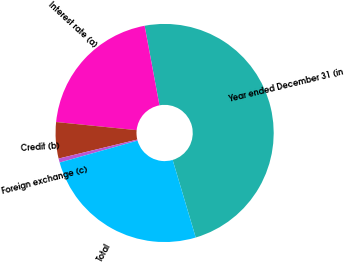<chart> <loc_0><loc_0><loc_500><loc_500><pie_chart><fcel>Year ended December 31 (in<fcel>Interest rate (a)<fcel>Credit (b)<fcel>Foreign exchange (c)<fcel>Total<nl><fcel>48.33%<fcel>20.46%<fcel>5.37%<fcel>0.6%<fcel>25.23%<nl></chart> 